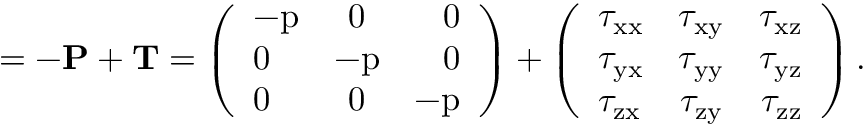Convert formula to latex. <formula><loc_0><loc_0><loc_500><loc_500>\Pi = - P + T = \left ( \begin{array} { l c r } { - p } & { 0 } & { 0 } \\ { 0 } & { - p } & { 0 } \\ { 0 } & { 0 } & { - p } \end{array} \right ) + \left ( \begin{array} { l c r } { \tau _ { x x } } & { \tau _ { x y } } & { \tau _ { x z } } \\ { \tau _ { y x } } & { \tau _ { y y } } & { \tau _ { y z } } \\ { \tau _ { z x } } & { \tau _ { z y } } & { \tau _ { z z } } \end{array} \right ) .</formula> 